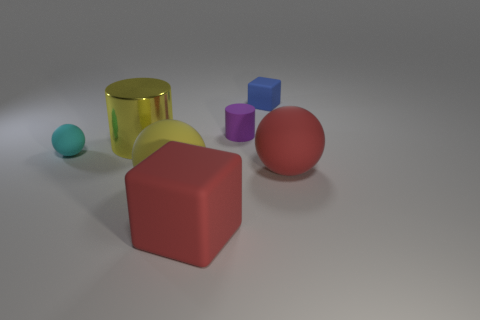Subtract all large rubber balls. How many balls are left? 1 Add 3 purple rubber objects. How many objects exist? 10 Subtract all cylinders. How many objects are left? 5 Subtract 0 red cylinders. How many objects are left? 7 Subtract all red things. Subtract all red rubber cubes. How many objects are left? 4 Add 5 tiny purple cylinders. How many tiny purple cylinders are left? 6 Add 6 large metallic things. How many large metallic things exist? 7 